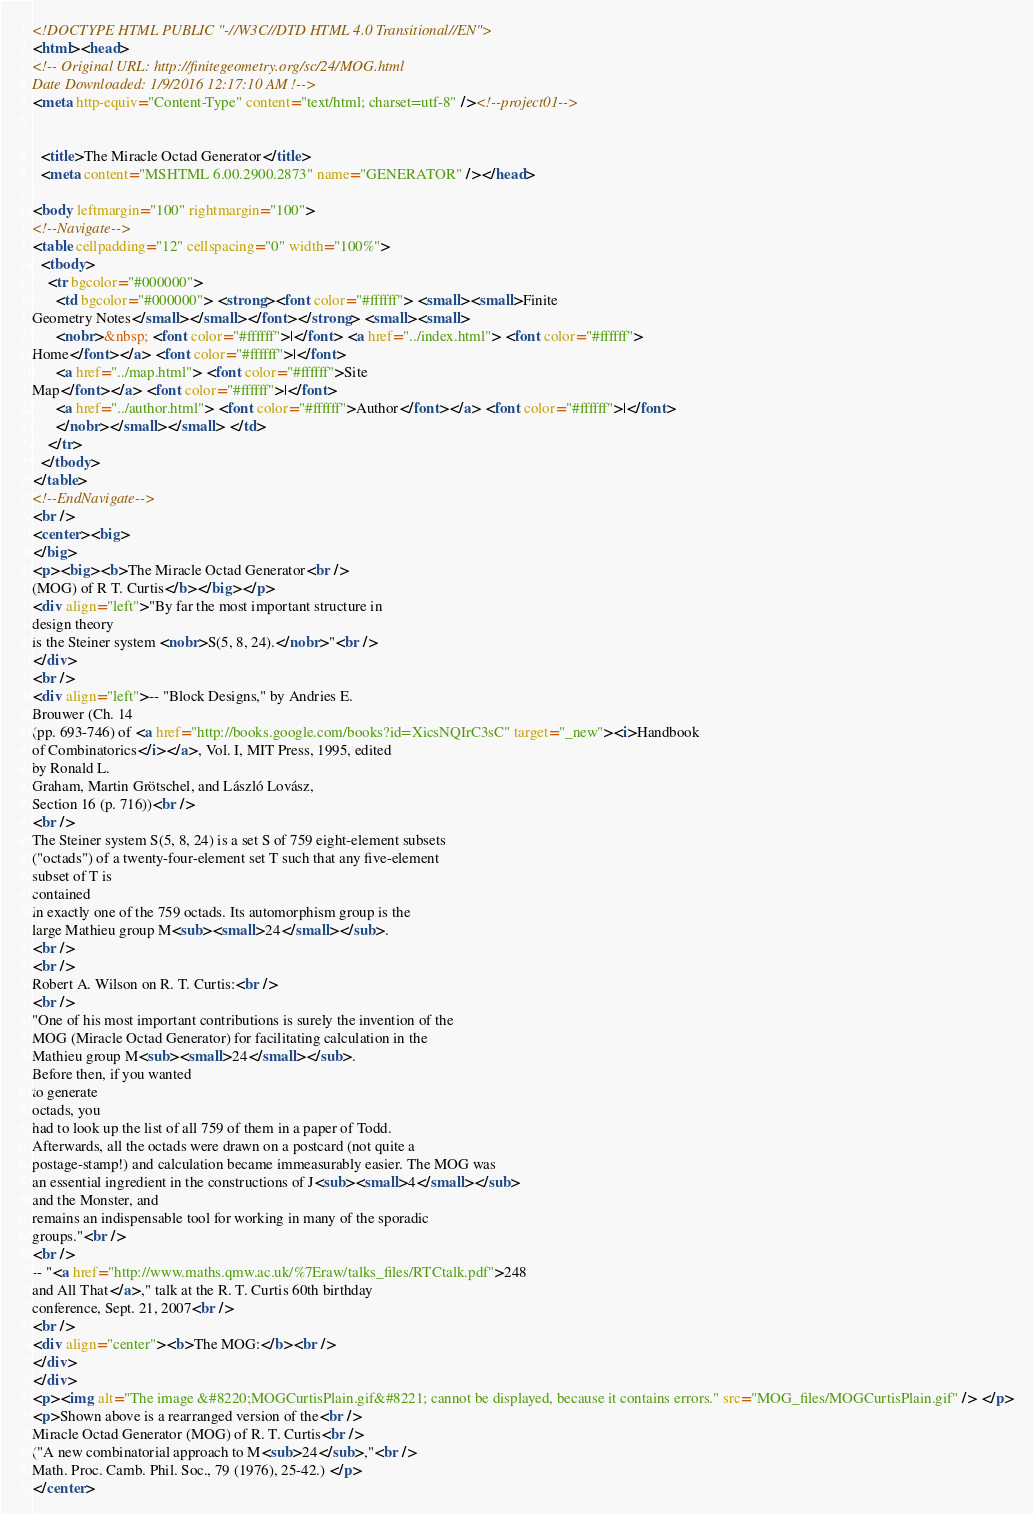<code> <loc_0><loc_0><loc_500><loc_500><_HTML_><!DOCTYPE HTML PUBLIC "-//W3C//DTD HTML 4.0 Transitional//EN">
<html><head>
<!-- Original URL: http://finitegeometry.org/sc/24/MOG.html
Date Downloaded: 1/9/2016 12:17:10 AM !-->
<meta http-equiv="Content-Type" content="text/html; charset=utf-8" /><!--project01-->

  
  <title>The Miracle Octad Generator</title>
  <meta content="MSHTML 6.00.2900.2873" name="GENERATOR" /></head>

<body leftmargin="100" rightmargin="100">
<!--Navigate-->
<table cellpadding="12" cellspacing="0" width="100%">
  <tbody>
    <tr bgcolor="#000000">
      <td bgcolor="#000000"> <strong><font color="#ffffff"> <small><small>Finite
Geometry Notes</small></small></font></strong> <small><small>
      <nobr>&nbsp; <font color="#ffffff">|</font> <a href="../index.html"> <font color="#ffffff">
Home</font></a> <font color="#ffffff">|</font>
      <a href="../map.html"> <font color="#ffffff">Site
Map</font></a> <font color="#ffffff">|</font>
      <a href="../author.html"> <font color="#ffffff">Author</font></a> <font color="#ffffff">|</font>
      </nobr></small></small> </td>
    </tr>
  </tbody>
</table>
<!--EndNavigate-->
<br />
<center><big>
</big>
<p><big><b>The Miracle Octad Generator<br />
(MOG) of R T. Curtis</b></big></p>
<div align="left">"By far the most important structure in
design theory
is the Steiner system <nobr>S(5, 8, 24).</nobr>"<br />
</div>
<br />
<div align="left">-- "Block Designs," by Andries E.
Brouwer (Ch. 14
(pp. 693-746) of <a href="http://books.google.com/books?id=XicsNQIrC3sC" target="_new"><i>Handbook
of Combinatorics</i></a>, Vol. I, MIT Press, 1995, edited
by Ronald L.
Graham, Martin Grötschel, and László Lovász,
Section 16 (p. 716))<br />
<br />
The Steiner system S(5, 8, 24) is a set S of 759 eight-element subsets
("octads") of a twenty-four-element set T such that any five-element
subset of T is
contained
in exactly one of the 759 octads. Its automorphism group is the
large Mathieu group M<sub><small>24</small></sub>.
<br />
<br />
Robert A. Wilson on R. T. Curtis:<br />
<br />
"One of his most important contributions is surely the invention of the
MOG (Miracle Octad Generator) for facilitating calculation in the
Mathieu group M<sub><small>24</small></sub>.
Before then, if you wanted
to generate
octads, you
had to look up the list of all 759 of them in a paper of Todd.
Afterwards, all the octads were drawn on a postcard (not quite a
postage-stamp!) and calculation became immeasurably easier. The MOG was
an essential ingredient in the constructions of J<sub><small>4</small></sub>
and the Monster, and
remains an indispensable tool for working in many of the sporadic
groups."<br />
<br />
-- "<a href="http://www.maths.qmw.ac.uk/%7Eraw/talks_files/RTCtalk.pdf">248
and All That</a>," talk at the R. T. Curtis 60th birthday
conference, Sept. 21, 2007<br />
<br />
<div align="center"><b>The MOG:</b><br />
</div>
</div>
<p><img alt="The image &#8220;MOGCurtisPlain.gif&#8221; cannot be displayed, because it contains errors." src="MOG_files/MOGCurtisPlain.gif" /> </p>
<p>Shown above is a rearranged version of the<br />
Miracle Octad Generator (MOG) of R. T. Curtis<br />
("A new combinatorial approach to M<sub>24</sub>,"<br />
Math. Proc. Camb. Phil. Soc., 79 (1976), 25-42.) </p>
</center></code> 